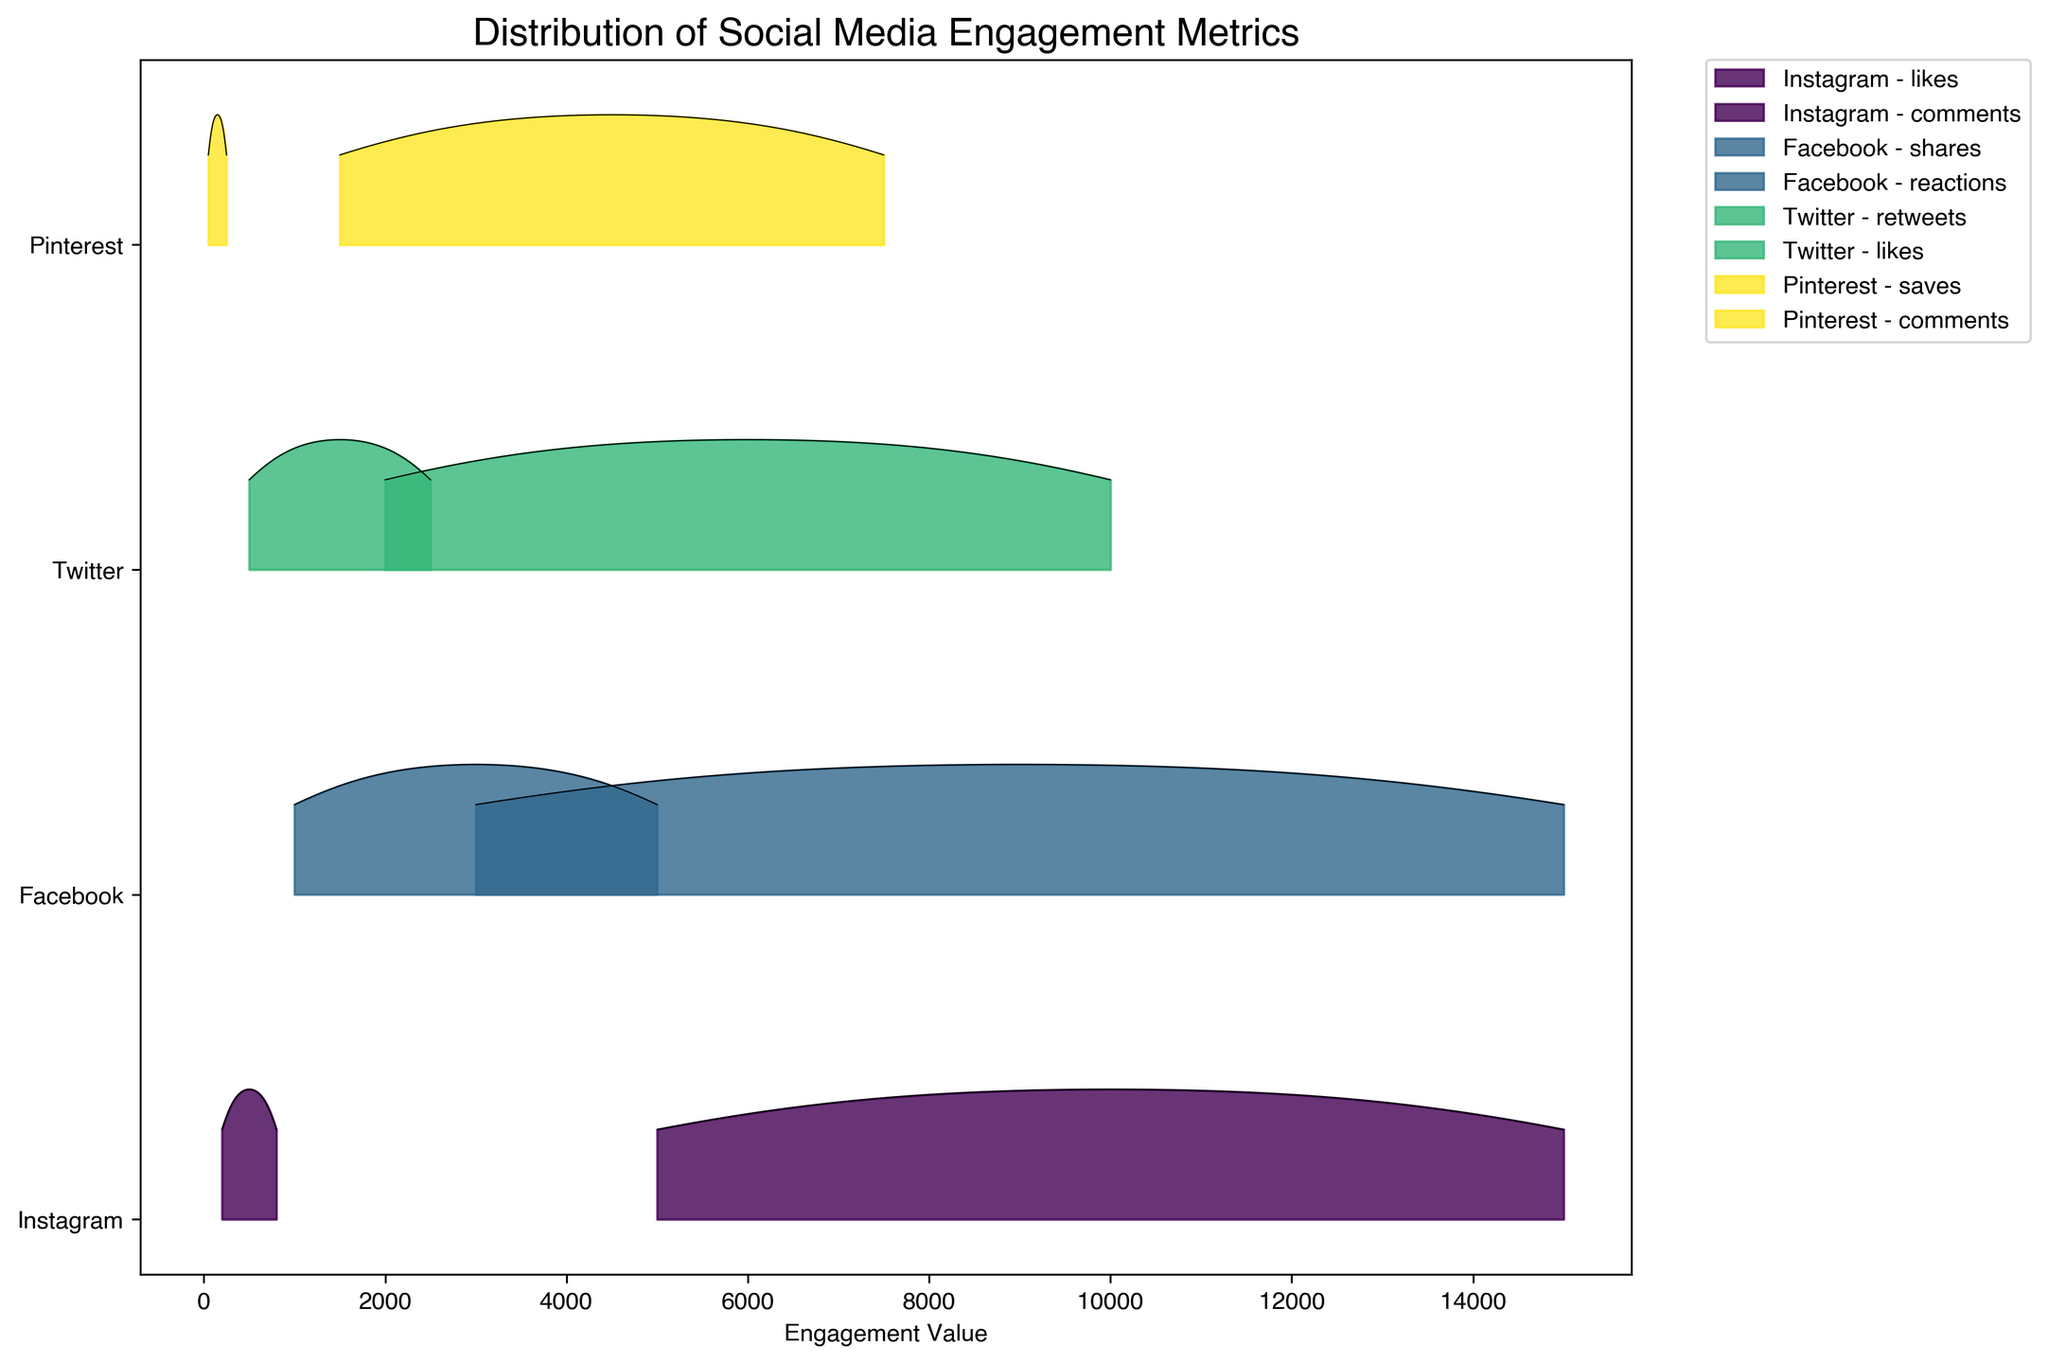What is the title of the figure? The title of the figure can be found at the top of the plot.
Answer: Distribution of Social Media Engagement Metrics What is the x-axis label in the figure? The x-axis label describes the data values measured on the horizontal axis. It can be found at the bottom of the plot on the horizontal line of the chart.
Answer: Engagement Value How many different platforms' engagement metrics are displayed in the figure? The number of different platforms can be determined by counting the unique labels on the y-axis.
Answer: 4 Which engagement metric on Instagram reaches the highest value? Identify the highest point in the plotted area for each engagement type on Instagram and check which one is the highest overall.
Answer: Likes How does the distribution of Facebook reactions compare to Facebook shares? Compare the density and spread of the plotted high-point areas for both reactions and shares under the Facebook label on the y-axis.
Answer: Facebook reactions have a wider distribution compared to Facebook shares Are Twitter likes generally higher or lower than Twitter retweets? Evaluate the density and peak areas for both likes and retweets under the Twitter label; move horizontally from left to right to see where the distributions peak.
Answer: Higher What is the range of values for Pinterest saves, based on the plot? The range can be found by identifying the minimum and maximum engagement values indicated for Pinterest saves in the plotted area on the x-axis.
Answer: 1500 to 7500 Compare the spread of engagement values for Instagram comments relative to Pinterest comments. Observe the range and distribution width on the x-axis for both Instagram and Pinterest comments to see which has a wider or narrower spread.
Answer: Instagram comments have a wider spread Which platform shows the largest variation in engagement metrics? The largest variation is determined by observing which platform has the widest range of engagement values across its metrics.
Answer: Facebook How are the ridgelines for different engagement metrics labeled differently from one another? The labels for different engagement metrics are typically identified by their positioning in the legend of the plot and their distinct colors and fills.
Answer: By different colors and platform-metric combinations in the legend 